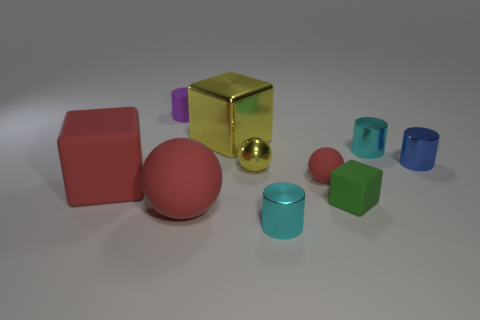Subtract all red matte balls. How many balls are left? 1 Subtract all brown cylinders. How many red balls are left? 2 Subtract all purple cylinders. How many cylinders are left? 3 Subtract all spheres. How many objects are left? 7 Subtract all red metallic spheres. Subtract all small rubber spheres. How many objects are left? 9 Add 7 big metallic objects. How many big metallic objects are left? 8 Add 6 large cylinders. How many large cylinders exist? 6 Subtract 0 brown cylinders. How many objects are left? 10 Subtract all green cylinders. Subtract all cyan balls. How many cylinders are left? 4 